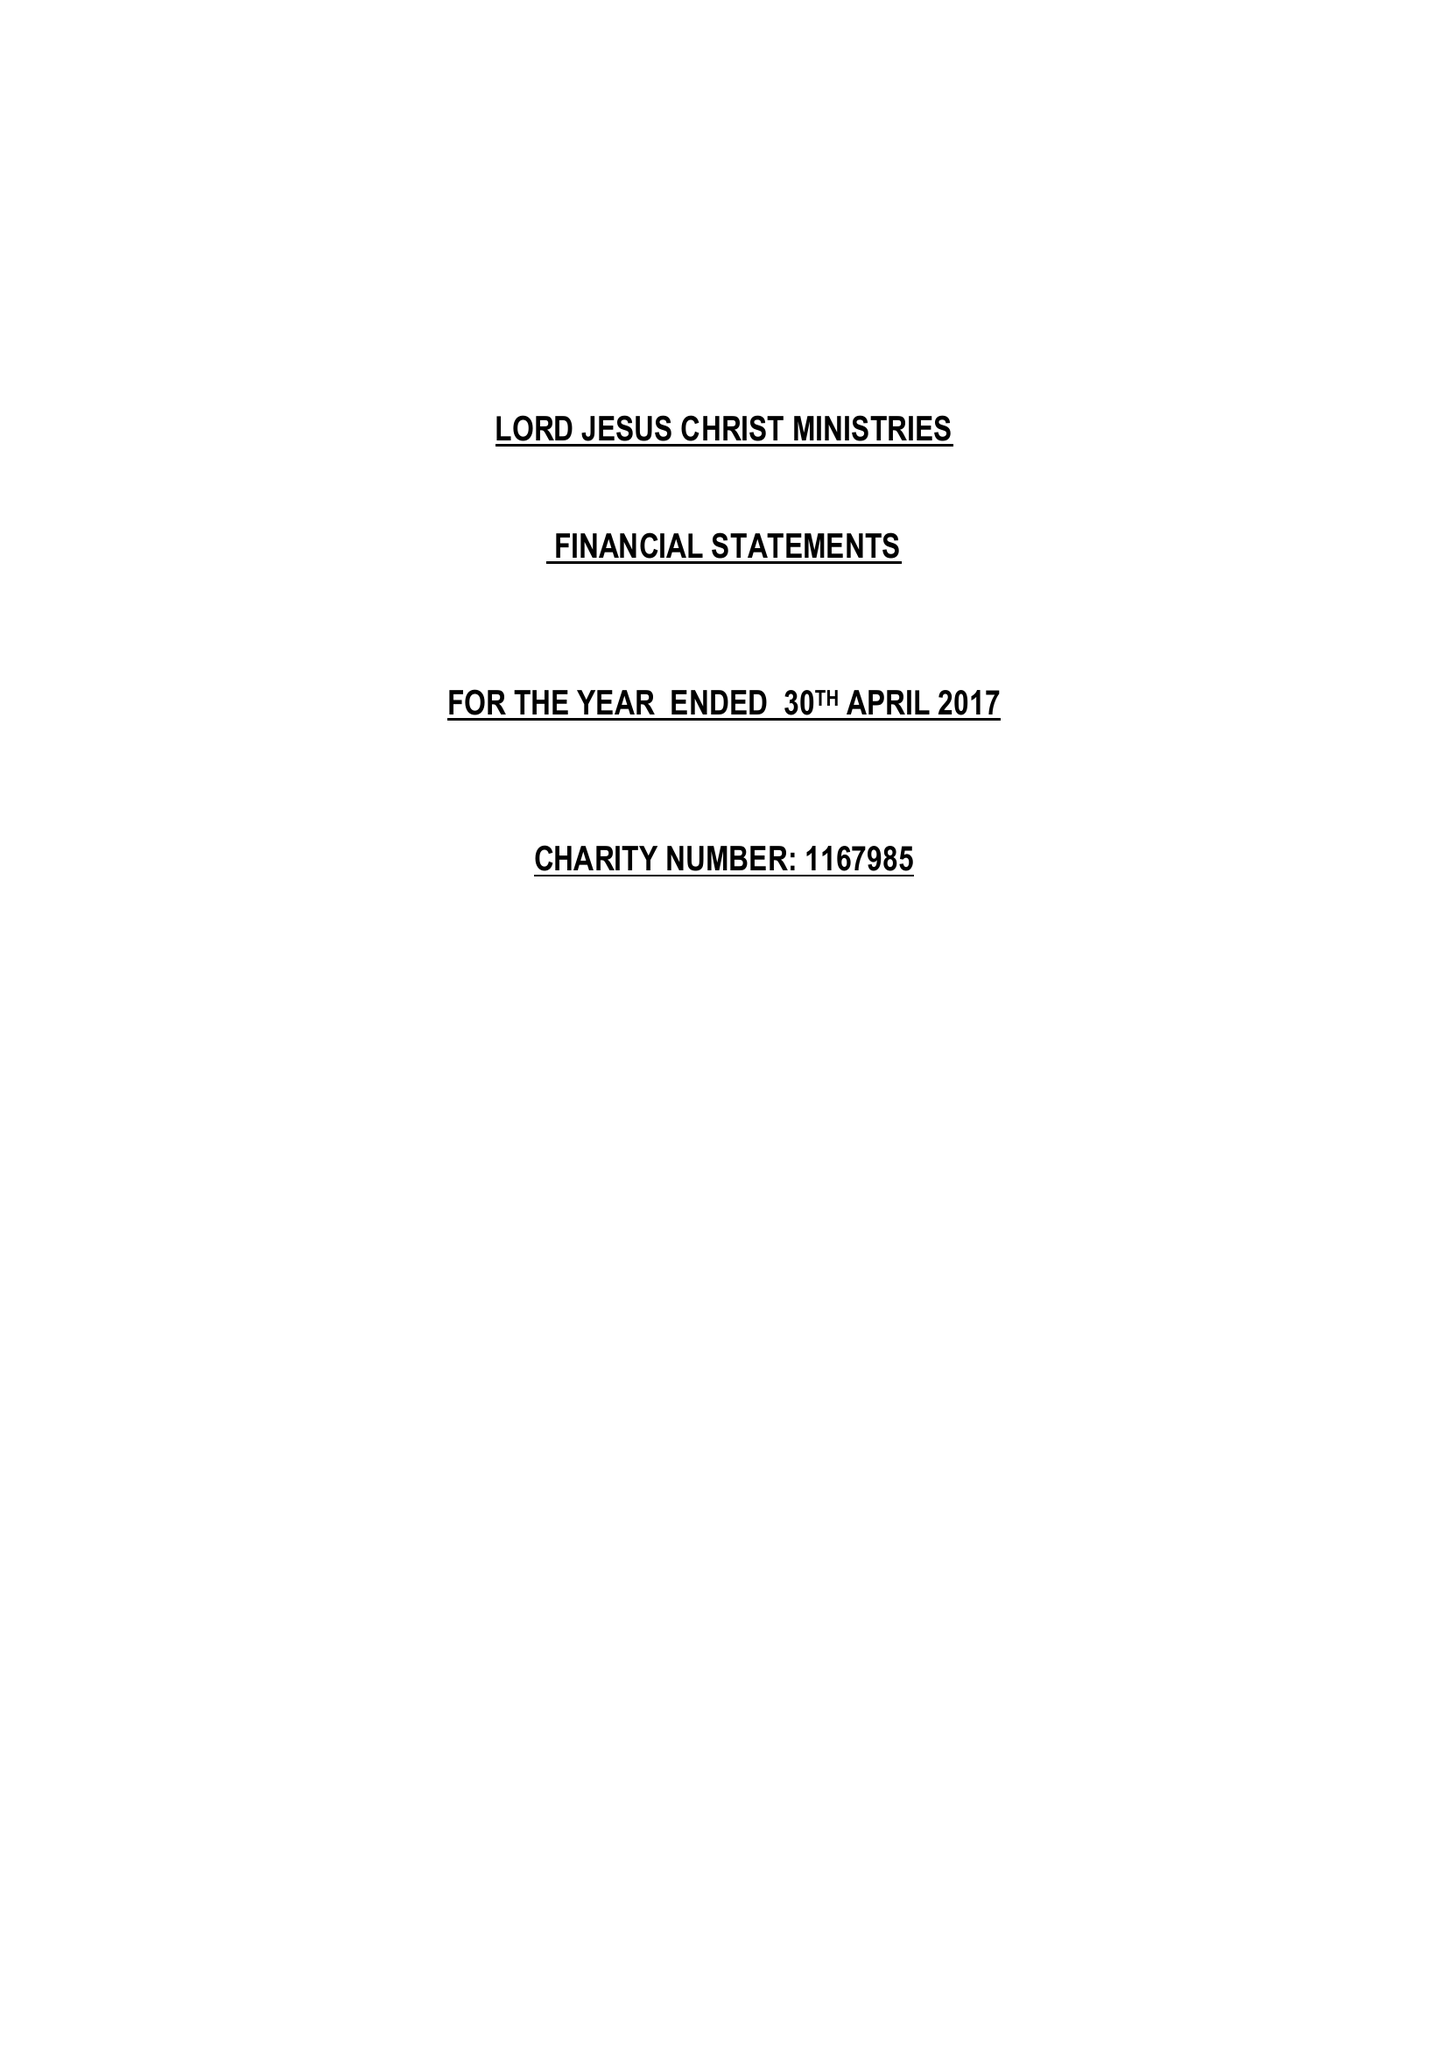What is the value for the spending_annually_in_british_pounds?
Answer the question using a single word or phrase. 2681.00 